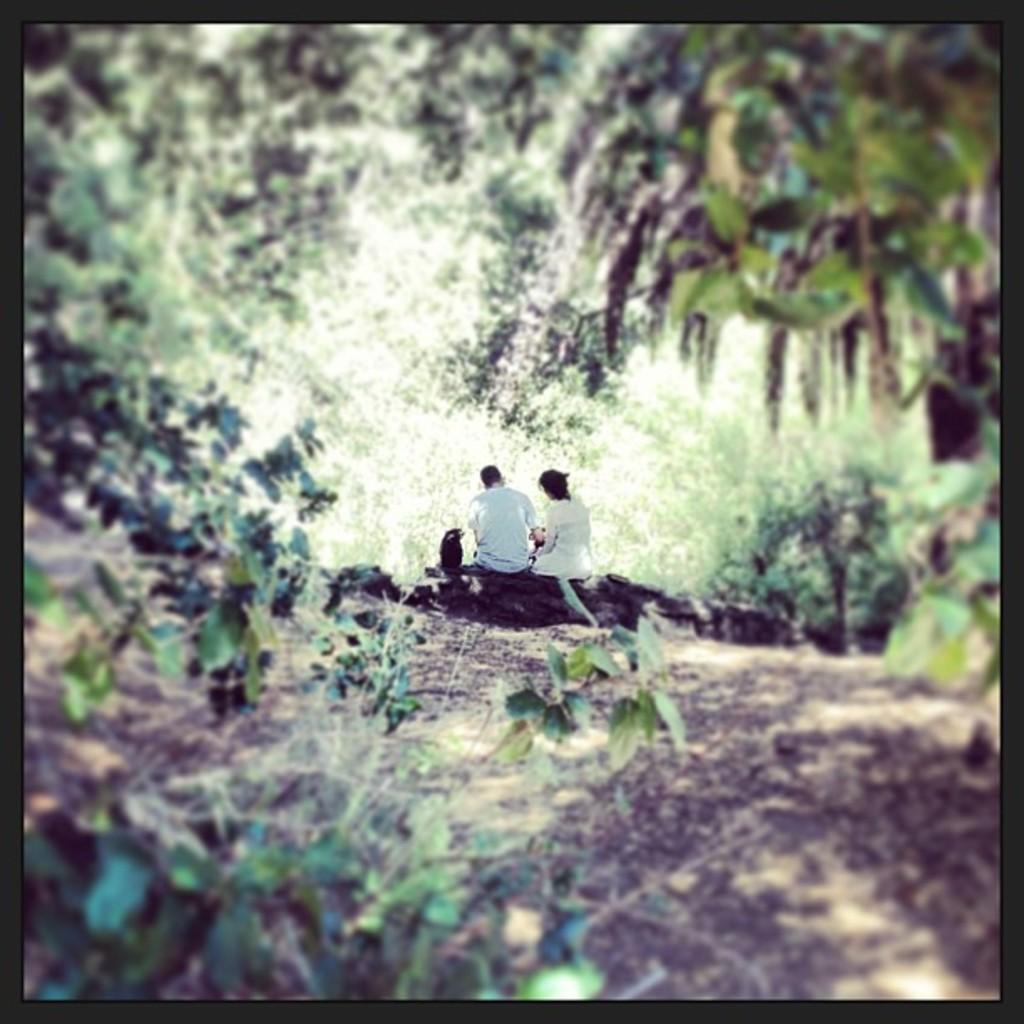How many people are in the image? There are two people in the image. What are the people doing in the image? The people are sitting on a rock. What type of vegetation can be seen in the image? Leaves are present in the image. What can be seen in the background of the image? There are trees in the background of the image. What type of work is being done by the people in the image? There is no indication of work being done in the image; the people are simply sitting on a rock. Can you tell me how many bananas are visible in the image? There are no bananas present in the image. 